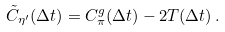Convert formula to latex. <formula><loc_0><loc_0><loc_500><loc_500>\tilde { C } _ { \eta ^ { \prime } } ( \Delta t ) = { C ^ { g } _ { \pi } ( \Delta t ) } - 2 T ( \Delta t ) \, .</formula> 